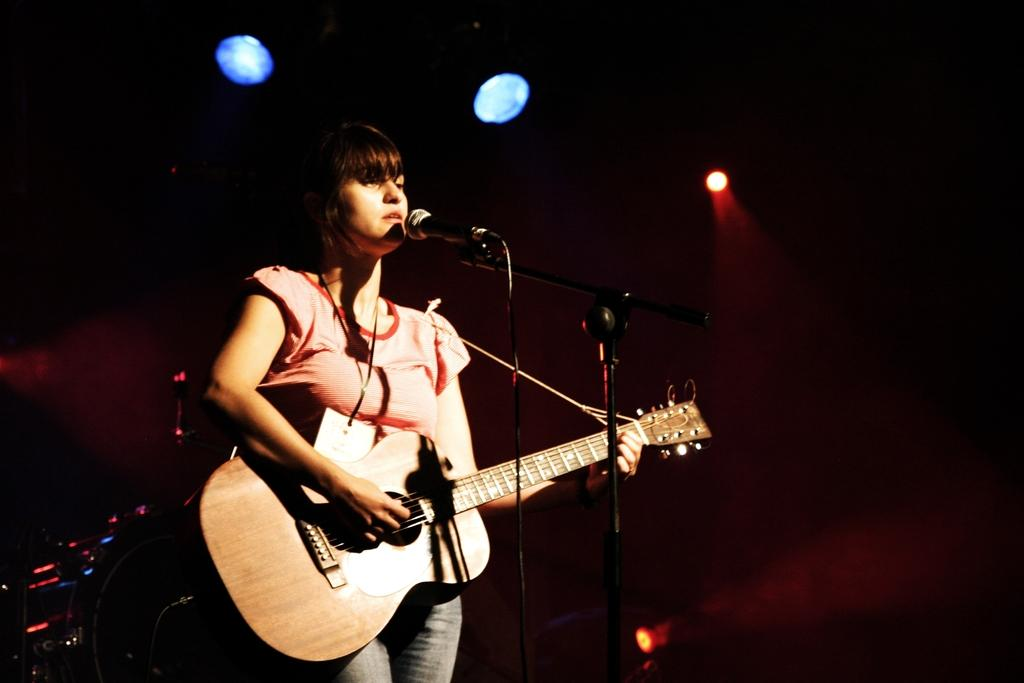What is the woman in the image doing? The woman is singing in the image. What object is the woman holding? The woman is holding a guitar. Where is the woman positioned in relation to the microphone? The woman is in front of a microphone. What can be seen in the background of the image? There is a light in the background of the image. What color is the woman's shirt in the image? The provided facts do not mention the color of the woman's shirt, so we cannot determine the color from the image. How does the woman end the song in the image? The provided facts do not mention the end of the song or any indication of the song's progress, so we cannot determine how the woman ends the song from the image. 